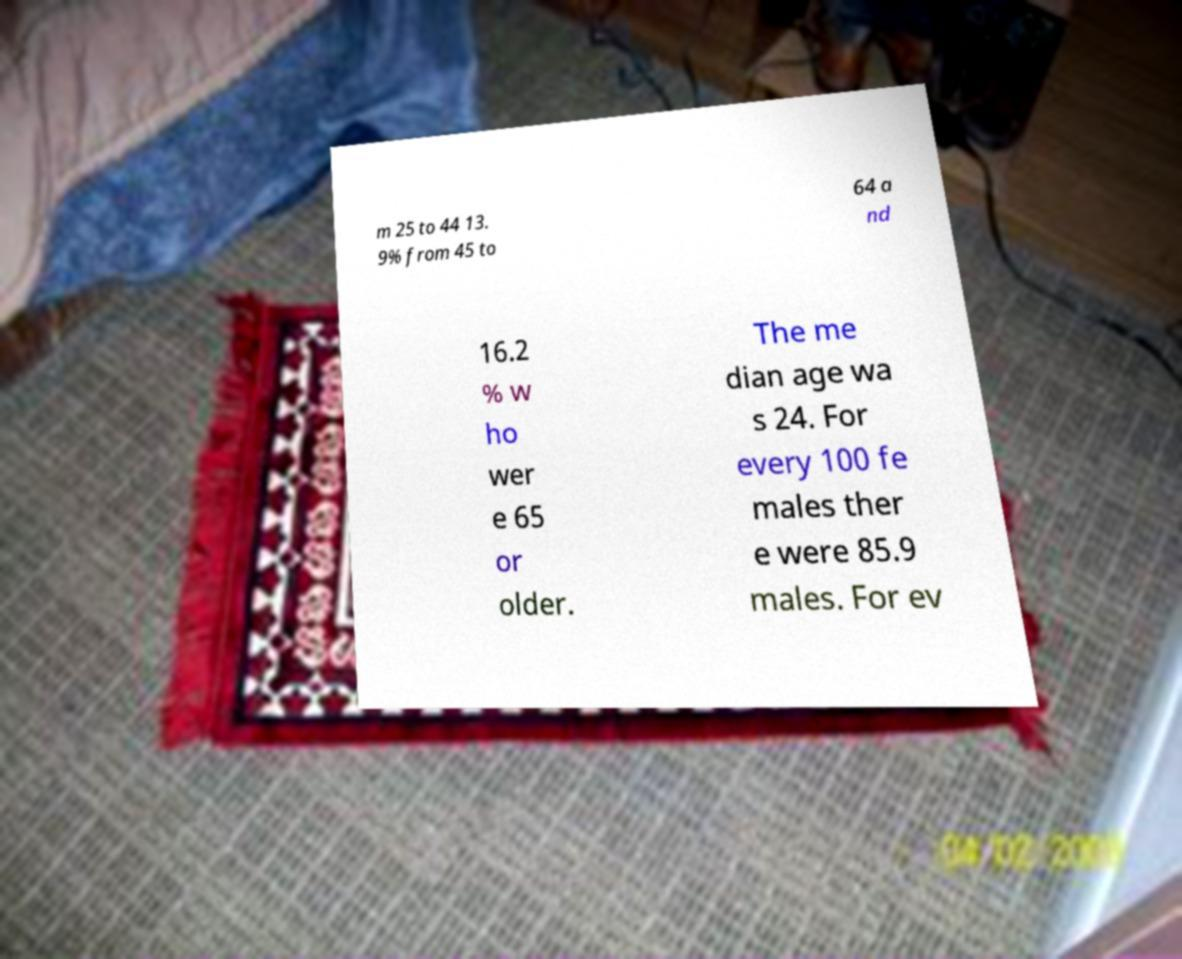Please identify and transcribe the text found in this image. m 25 to 44 13. 9% from 45 to 64 a nd 16.2 % w ho wer e 65 or older. The me dian age wa s 24. For every 100 fe males ther e were 85.9 males. For ev 